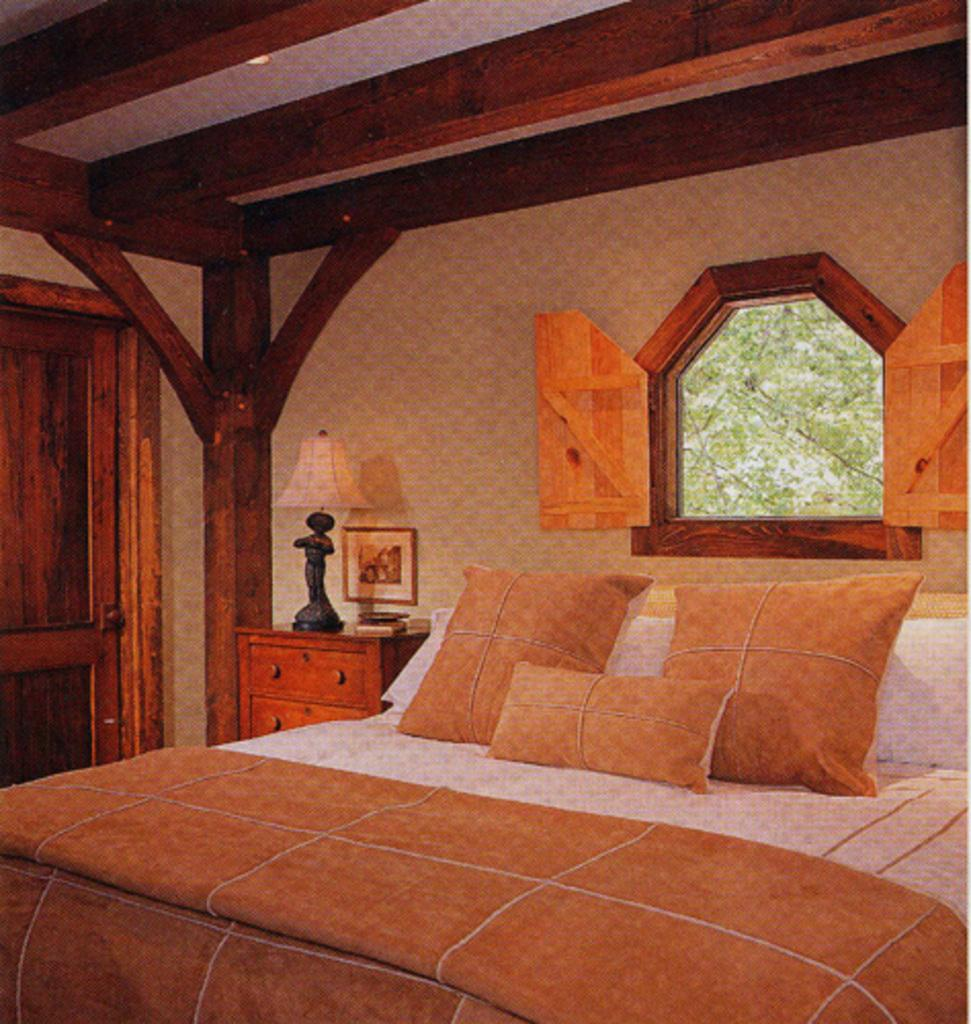What type of room is shown in the image? The image is an inside view of a house, specifically a room. What furniture is present in the room? There is a bed with bed sheets and pillows in the image. What can be seen on the wall in the background? There is a photo frame on the wall. What other objects are visible in the background? There is a lamp, a wooden desk, a door, a pillar, and a window in the background of the image. What type of jam is being spread on the pillar in the image? There is no jam or any food item present in the image, and therefore no such activity can be observed. 